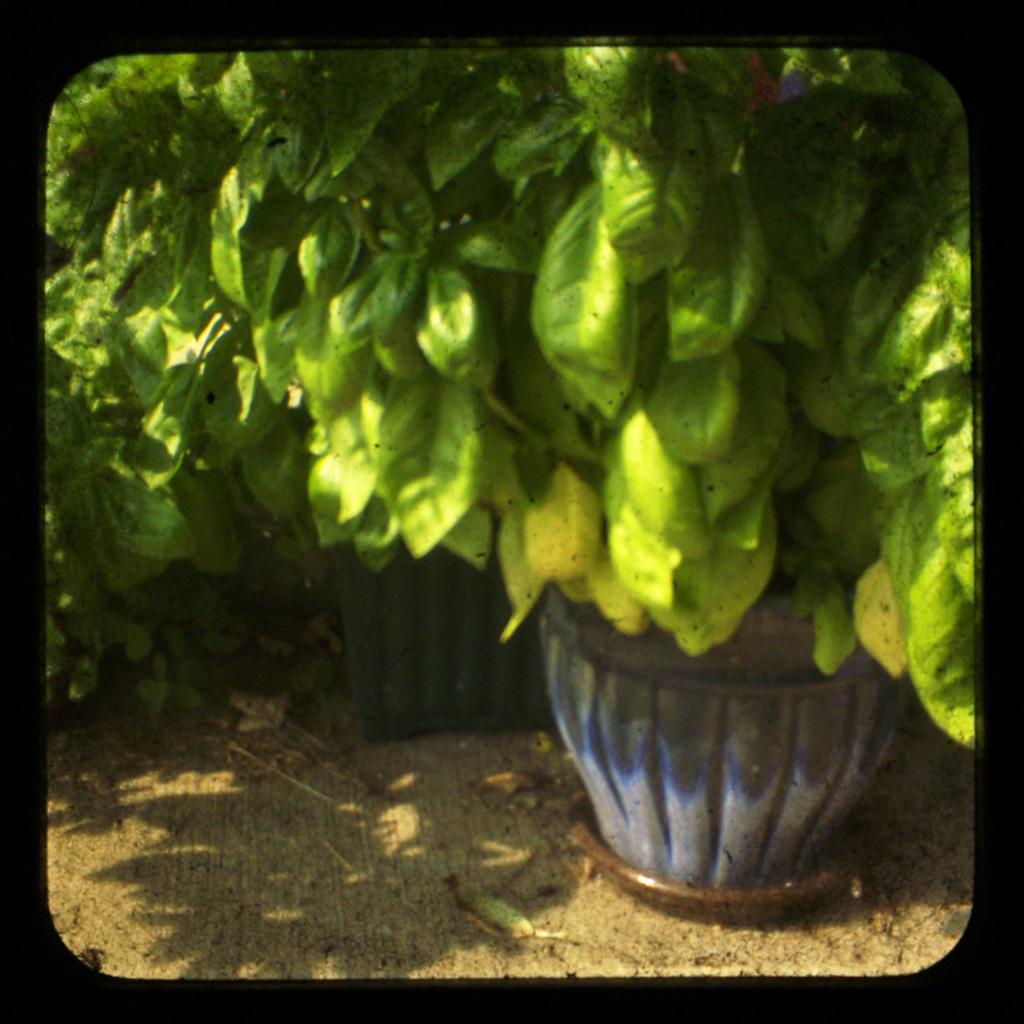Could you give a brief overview of what you see in this image? In the image there are plant pots on the land. 